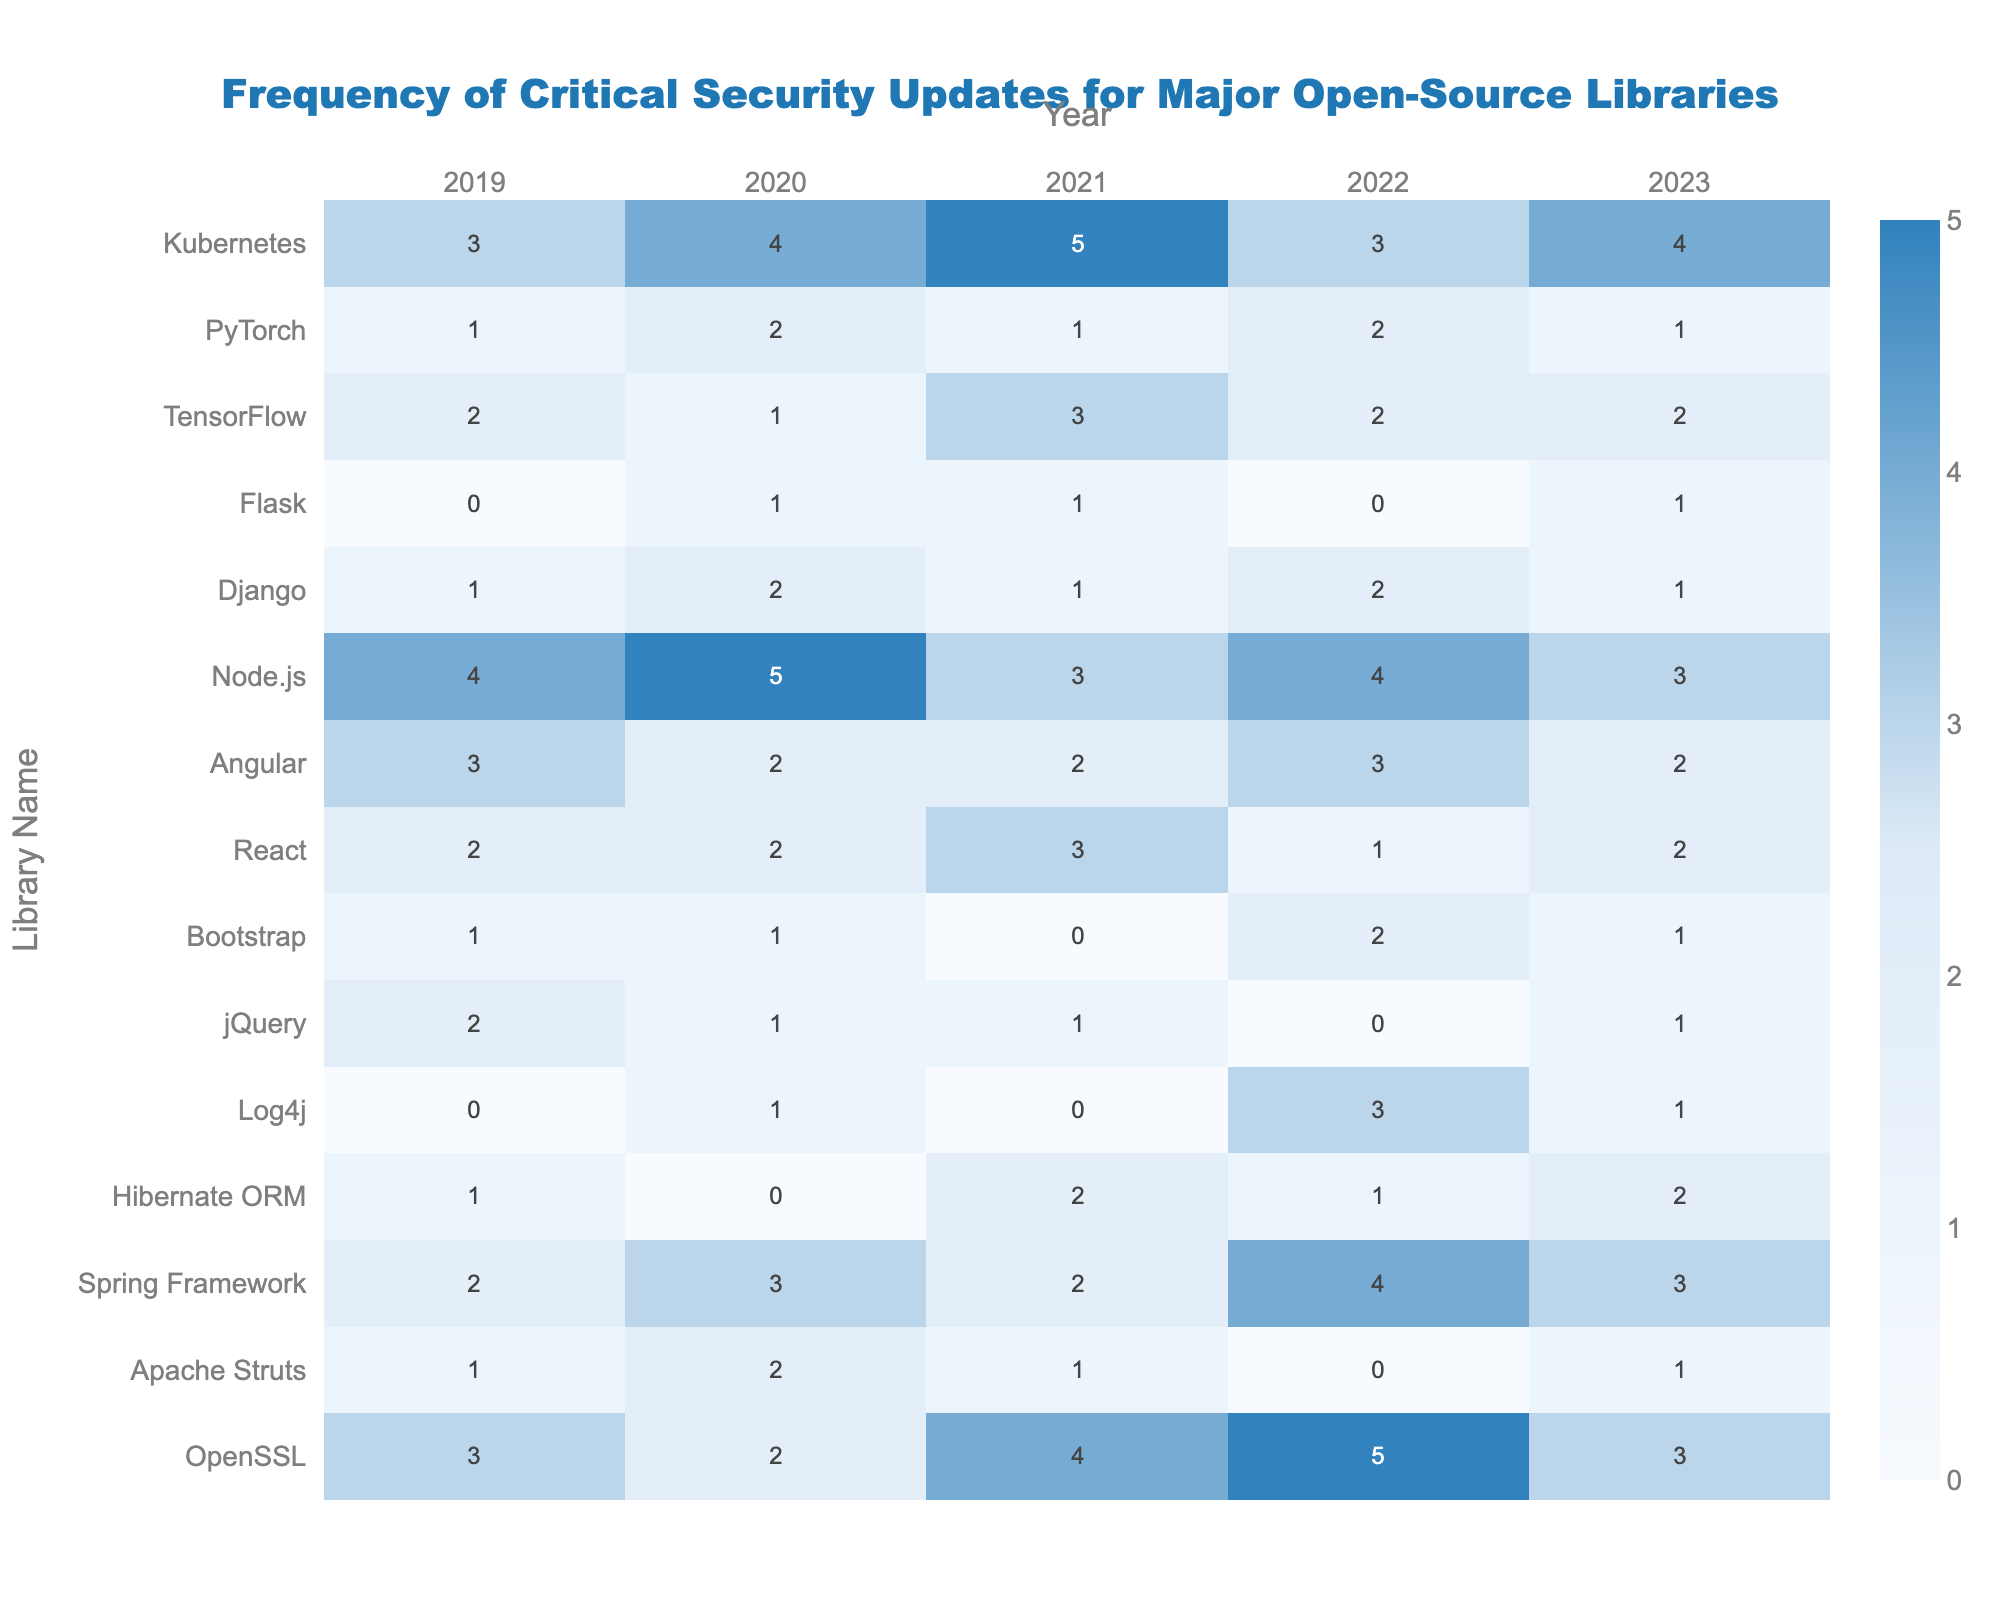What is the highest frequency of critical security updates recorded for any library in 2021? The highest frequency of critical security updates can be found by examining the data for 2021. OpenSSL has the highest count with 4 updates.
Answer: 4 How many critical security updates did Apache Struts receive in total from 2019 to 2023? To find the total updates for Apache Struts, sum the values from all years: 1 + 2 + 1 + 0 + 1 = 5.
Answer: 5 Did Hibernate ORM receive more updates in 2022 than in 2023? In 2022, Hibernate ORM received 1 update, while in 2023, it received 2 updates. Therefore, it did not receive more updates in 2022.
Answer: No Which library had the most significant decrease in updates from 2020 to 2021? To compare the updates, look at each library's values from 2020 to 2021: Apache Struts decreased from 2 to 1, and Hibernate ORM decreased from 0 to 2. The highest decrease is such a comparison results shows Hibernate ORM has only 1 update in 2021, thus Apache Struts had the highest reduction from 2 to 1.
Answer: Apache Struts What is the average number of updates for Node.js over the five years? First, sum the updates for Node.js: 4 + 5 + 3 + 4 + 3 = 19. Then divide by the number of years (5): 19/5 = 3.8.
Answer: 3.8 In which year did the React library have its peak frequency of updates? Looking through the data, React had its peak in 2021 with 3 updates compared to other years.
Answer: 2021 Is it true that all libraries had at least one critical security update in 2022? Examining the data shows that Apache Struts and Flask both had 0 updates in 2022, therefore the statement is false.
Answer: False What is the combined total of critical security updates for the Spring Framework and TensorFlow from 2019 to 2023? For Spring Framework, the total is 2 + 3 + 2 + 4 + 3 = 14. For TensorFlow, the total is 2 + 1 + 3 + 2 + 2 = 10. Adding both gives 14 + 10 = 24.
Answer: 24 Which library consistently had zero updates across multiple years? By checking the data, Log4j had zero updates for both 2019 and 2021, making it the library with no consistent updates.
Answer: Log4j What was the change in the number of updates for Flask from 2019 to 2023? Flask had 0 updates in 2019 and 1 update in 2023. Thus, the change is 1 - 0 = 1.
Answer: 1 How many libraries had more updates in 2022 compared to 2021? From the data, comparing 2022 to 2021, the libraries with more updates in 2022 than in 2021 are OpenSSL, Spring Framework, and React. Therefore, there are 3 libraries.
Answer: 3 